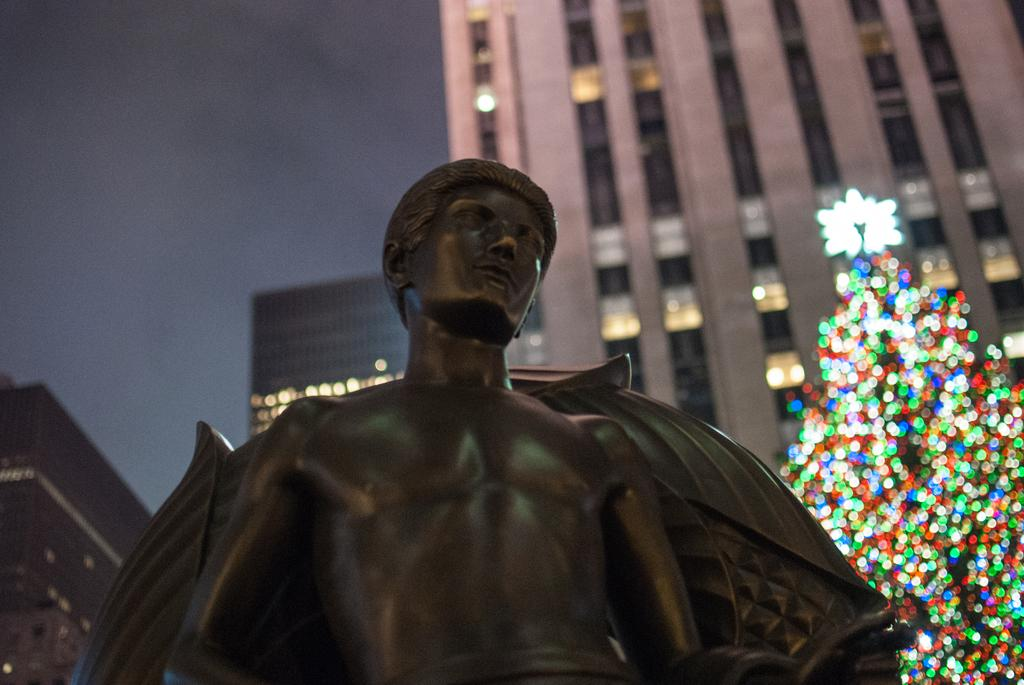What is the main subject in the image? There is a statue in the image. What is located behind the statue? There is a tree with decorative lights on the backside of the statue. What type of structures can be seen in the image? There are buildings visible in the image. What is visible in the background of the image? The sky is visible in the image. How many times does the statue cough in the image? The statue does not cough in the image, as it is a statue and not a living being. 